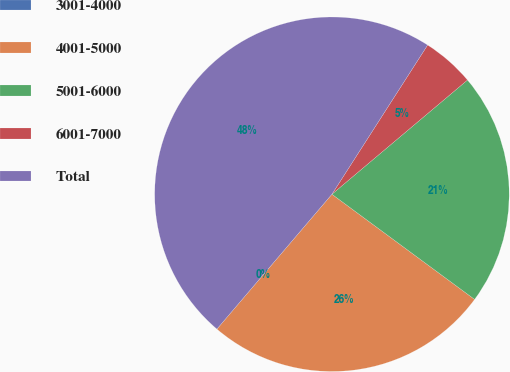Convert chart. <chart><loc_0><loc_0><loc_500><loc_500><pie_chart><fcel>3001-4000<fcel>4001-5000<fcel>5001-6000<fcel>6001-7000<fcel>Total<nl><fcel>0.0%<fcel>26.13%<fcel>21.25%<fcel>4.78%<fcel>47.83%<nl></chart> 